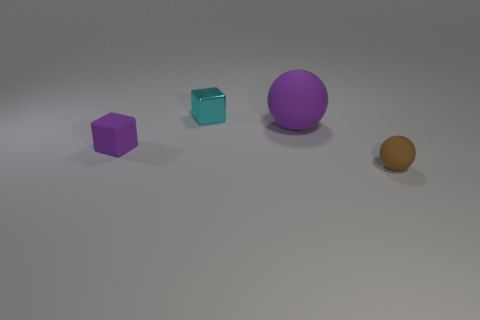How many spheres are purple matte things or small brown things?
Give a very brief answer. 2. The cyan metallic object that is the same shape as the small purple object is what size?
Offer a terse response. Small. How many brown rubber objects are there?
Your answer should be very brief. 1. Do the big purple rubber thing and the small rubber thing right of the large purple rubber ball have the same shape?
Offer a very short reply. Yes. There is a purple matte object that is to the right of the small purple rubber thing; what is its size?
Keep it short and to the point. Large. What is the purple sphere made of?
Ensure brevity in your answer.  Rubber. Is the shape of the purple thing on the right side of the metal object the same as  the brown object?
Your response must be concise. Yes. The cube that is the same color as the big matte object is what size?
Provide a short and direct response. Small. Are there any purple spheres of the same size as the metallic thing?
Offer a very short reply. No. Are there any small purple cubes behind the small matte object that is behind the tiny matte object that is in front of the small purple cube?
Offer a very short reply. No. 